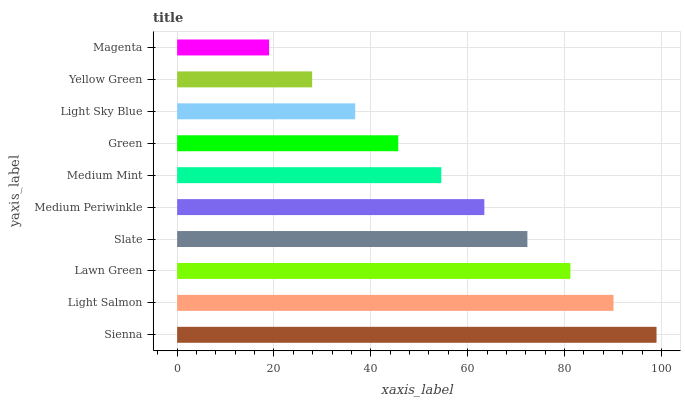Is Magenta the minimum?
Answer yes or no. Yes. Is Sienna the maximum?
Answer yes or no. Yes. Is Light Salmon the minimum?
Answer yes or no. No. Is Light Salmon the maximum?
Answer yes or no. No. Is Sienna greater than Light Salmon?
Answer yes or no. Yes. Is Light Salmon less than Sienna?
Answer yes or no. Yes. Is Light Salmon greater than Sienna?
Answer yes or no. No. Is Sienna less than Light Salmon?
Answer yes or no. No. Is Medium Periwinkle the high median?
Answer yes or no. Yes. Is Medium Mint the low median?
Answer yes or no. Yes. Is Light Salmon the high median?
Answer yes or no. No. Is Magenta the low median?
Answer yes or no. No. 